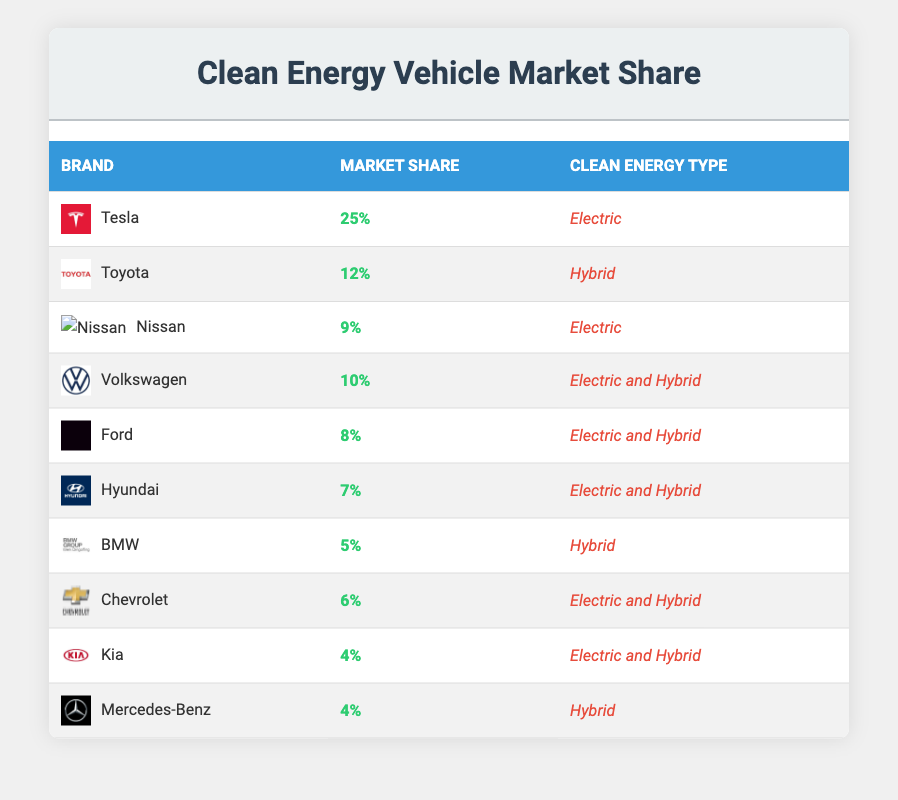What brand has the highest market share in clean energy vehicles? Looking at the table, Tesla has a market share of 25%, which is the highest among all listed brands.
Answer: Tesla How many brands have a market share of 10% or higher? By examining the table, the brands with a market share of 10% or higher are Tesla (25%), Toyota (12%), and Volkswagen (10%). This gives us a total of three brands.
Answer: 3 Is Ford's market share greater than Hyundai's? Ford has a market share of 8%, while Hyundai has a market share of 7%. Therefore, Ford's market share is greater than Hyundai's.
Answer: Yes Which types of clean energy vehicles does Volkswagen offer? The table indicates that Volkswagen offers both Electric and Hybrid types of clean energy vehicles.
Answer: Electric and Hybrid What is the total market share of all brands listed in the table? To find the total market share, we add the market shares of all brands: 25 + 12 + 9 + 10 + 8 + 7 + 5 + 6 + 4 + 4 = 100. Therefore, the total market share is 100%.
Answer: 100% Does Nissan have a higher market share than Kia? Nissan has a market share of 9%, while Kia has a market share of 4%. Thus, Nissan has a higher market share than Kia.
Answer: Yes What percentage of the market share is held by Hybrid vehicle brands? The brands with Hybrid vehicles are Toyota (12%), Volkswagen (10%), Ford (8%), BMW (5%), and Mercedes-Benz (4%). Summing these gives us 12 + 10 + 8 + 5 + 4 = 39%. Therefore, Hybrid vehicle brands hold 39% of the market share.
Answer: 39% Which brand has the lowest market share in clean energy vehicles? By analyzing the table, Kia and Mercedes-Benz both have the lowest market share at 4%.
Answer: Kia and Mercedes-Benz How many brands in the table focus solely on electric vehicles? According to the entries, the brands focusing solely on electric vehicles are Tesla (25%) and Nissan (9%). This gives us a total of two brands.
Answer: 2 